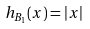<formula> <loc_0><loc_0><loc_500><loc_500>h _ { B _ { 1 } } ( x ) = | x |</formula> 